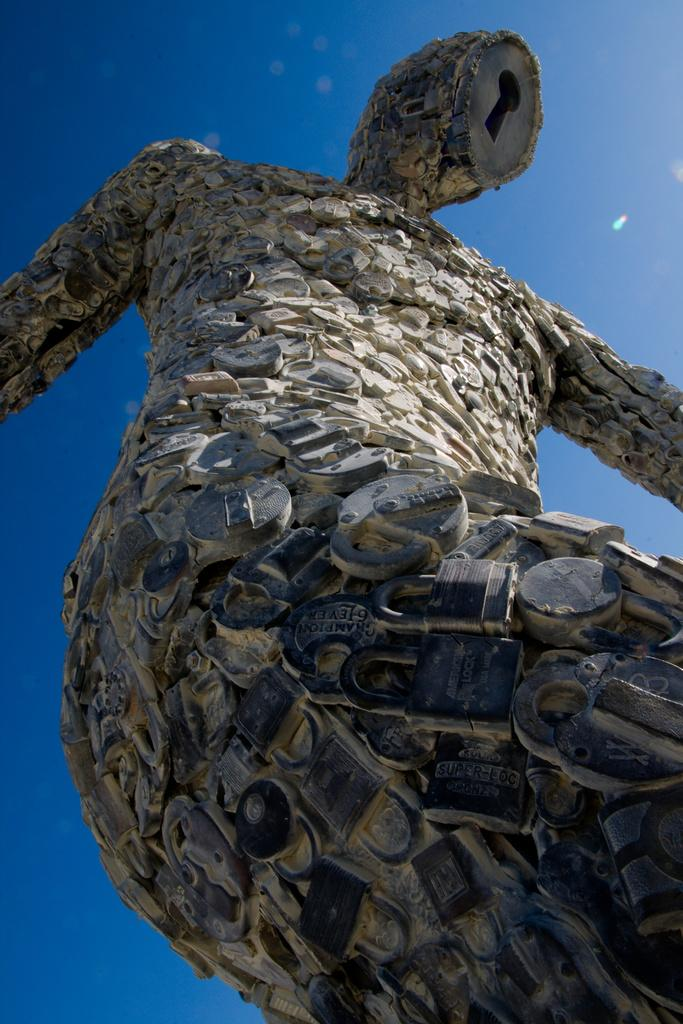What is the main subject of the image? There is a statue in the image. What can be seen in the background of the image? The sky is visible in the image. What type of riddle is the statue trying to solve in the image? There is no indication in the image that the statue is trying to solve a riddle. 